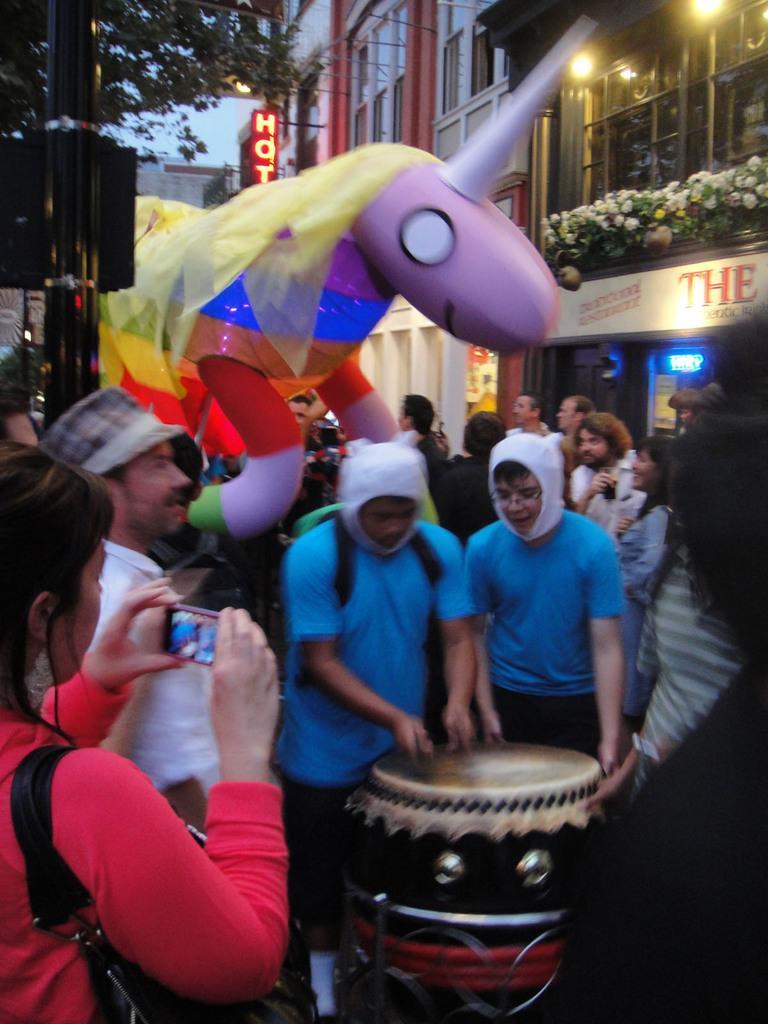Could you give a brief overview of what you see in this image? There is a group of people. They all are standing. On the right side we have a two persons. They both are wearing colorful shirts. They both are wearing white color caps. On the left side we have a woman. She is wearing a bag and she is holding a mobile. She is watching a video. The background we can see the beautiful sky ,trees,flower vases. 